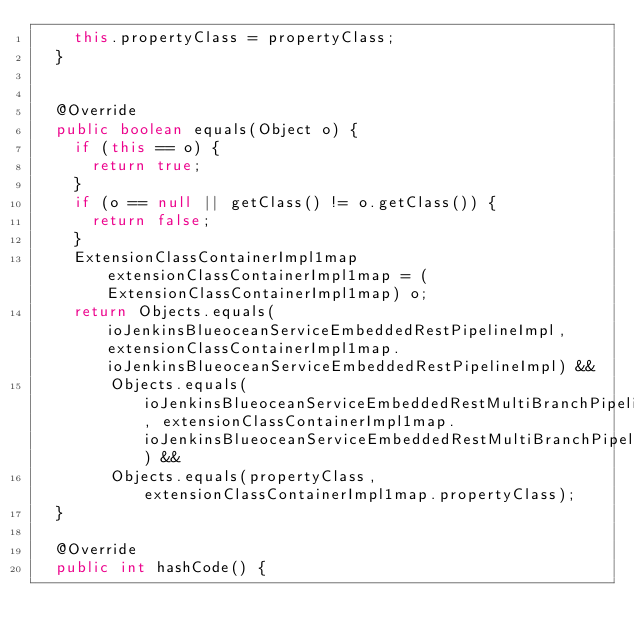Convert code to text. <code><loc_0><loc_0><loc_500><loc_500><_Java_>    this.propertyClass = propertyClass;
  }


  @Override
  public boolean equals(Object o) {
    if (this == o) {
      return true;
    }
    if (o == null || getClass() != o.getClass()) {
      return false;
    }
    ExtensionClassContainerImpl1map extensionClassContainerImpl1map = (ExtensionClassContainerImpl1map) o;
    return Objects.equals(ioJenkinsBlueoceanServiceEmbeddedRestPipelineImpl, extensionClassContainerImpl1map.ioJenkinsBlueoceanServiceEmbeddedRestPipelineImpl) &&
        Objects.equals(ioJenkinsBlueoceanServiceEmbeddedRestMultiBranchPipelineImpl, extensionClassContainerImpl1map.ioJenkinsBlueoceanServiceEmbeddedRestMultiBranchPipelineImpl) &&
        Objects.equals(propertyClass, extensionClassContainerImpl1map.propertyClass);
  }

  @Override
  public int hashCode() {</code> 